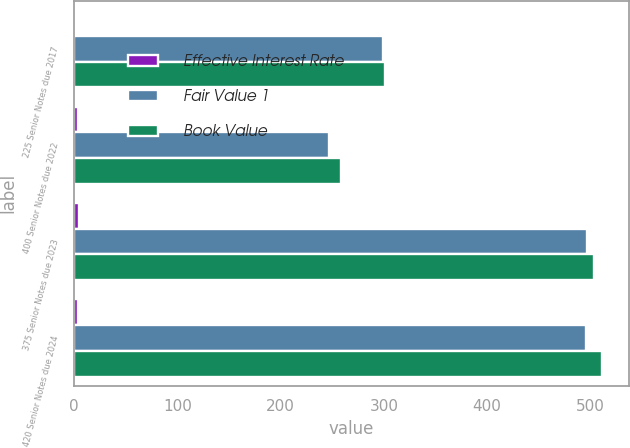Convert chart to OTSL. <chart><loc_0><loc_0><loc_500><loc_500><stacked_bar_chart><ecel><fcel>225 Senior Notes due 2017<fcel>400 Senior Notes due 2022<fcel>375 Senior Notes due 2023<fcel>420 Senior Notes due 2024<nl><fcel>Effective Interest Rate<fcel>2.3<fcel>4.13<fcel>4.32<fcel>4.24<nl><fcel>Fair Value 1<fcel>299.4<fcel>247<fcel>496.6<fcel>496.2<nl><fcel>Book Value<fcel>301.4<fcel>258.4<fcel>503.3<fcel>511.6<nl></chart> 